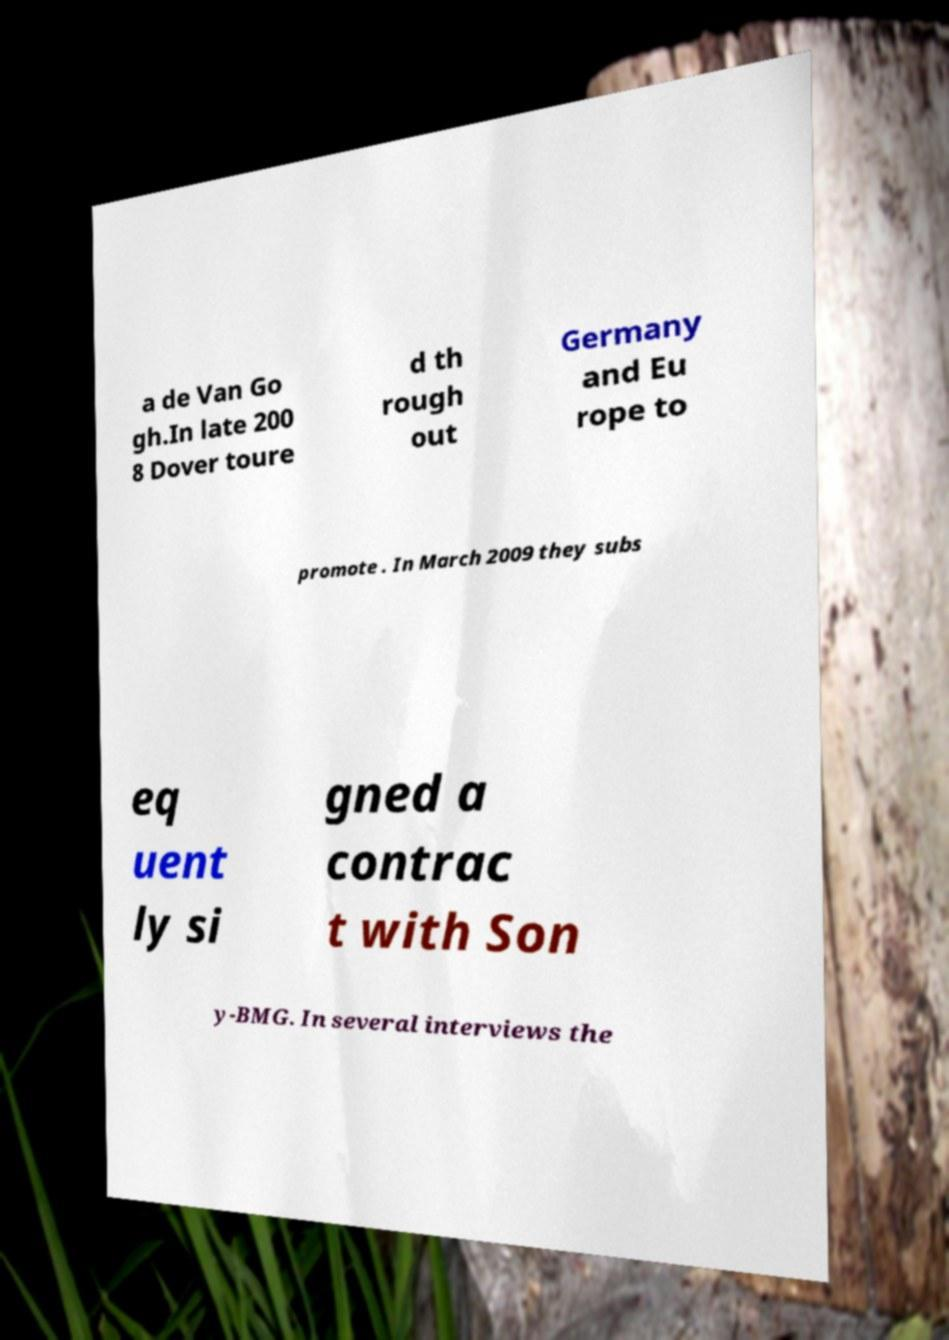Please identify and transcribe the text found in this image. a de Van Go gh.In late 200 8 Dover toure d th rough out Germany and Eu rope to promote . In March 2009 they subs eq uent ly si gned a contrac t with Son y-BMG. In several interviews the 